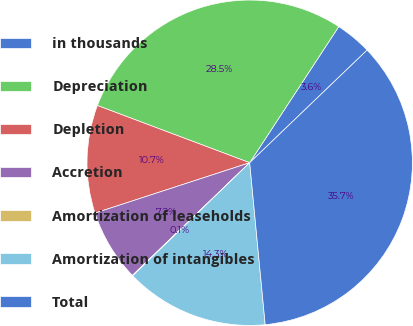Convert chart. <chart><loc_0><loc_0><loc_500><loc_500><pie_chart><fcel>in thousands<fcel>Depreciation<fcel>Depletion<fcel>Accretion<fcel>Amortization of leaseholds<fcel>Amortization of intangibles<fcel>Total<nl><fcel>3.61%<fcel>28.5%<fcel>10.73%<fcel>7.17%<fcel>0.05%<fcel>14.29%<fcel>35.65%<nl></chart> 